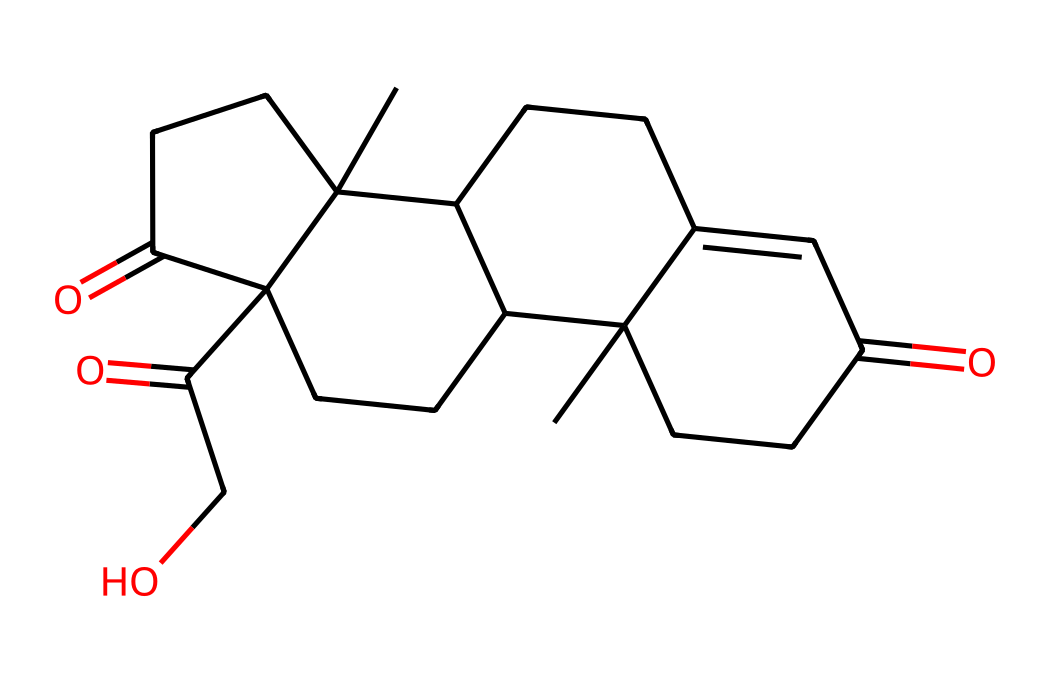How many carbon atoms are in cortisol? By analyzing the provided SMILES representation, we can count the number of 'C' characters, which represent carbon atoms. The structure shows a total of 21 carbon atoms.
Answer: 21 What is the primary functional group present in cortisol? From the SMILES representation, we can identify the 'O' characters, which indicate the presence of carbonyl (C=O) groups, and single 'O' characters connected to carbon atoms, indicating alcohol (—OH) groups. The primary functional group here is the ketone (C=O).
Answer: ketone How many rings are present in the structure of cortisol? In the provided SMILES, we can observe the numbers indicating where the rings close on the carbon atoms. Counting them reveals that there are 4 rings in the structure of cortisol.
Answer: 4 Does cortisol contain any double bonds? Examining the SMILES, the presence of '=' symbols indicates double bonds. In cortisol's structure, there are 3 occurrences of double bonds, confirming that it does have double bonds.
Answer: yes Which specific type of phosphorus compound can cortisol be classified as? Although cortisol itself is a steroid structure, the question regarding phosphorus compounds refers to its metabolic interaction with phosphates in the biological system. Cortisol can influence phosphorylation but is not a phosphorus compound directly. Thus, it’s classified as a steroid.
Answer: steroid 